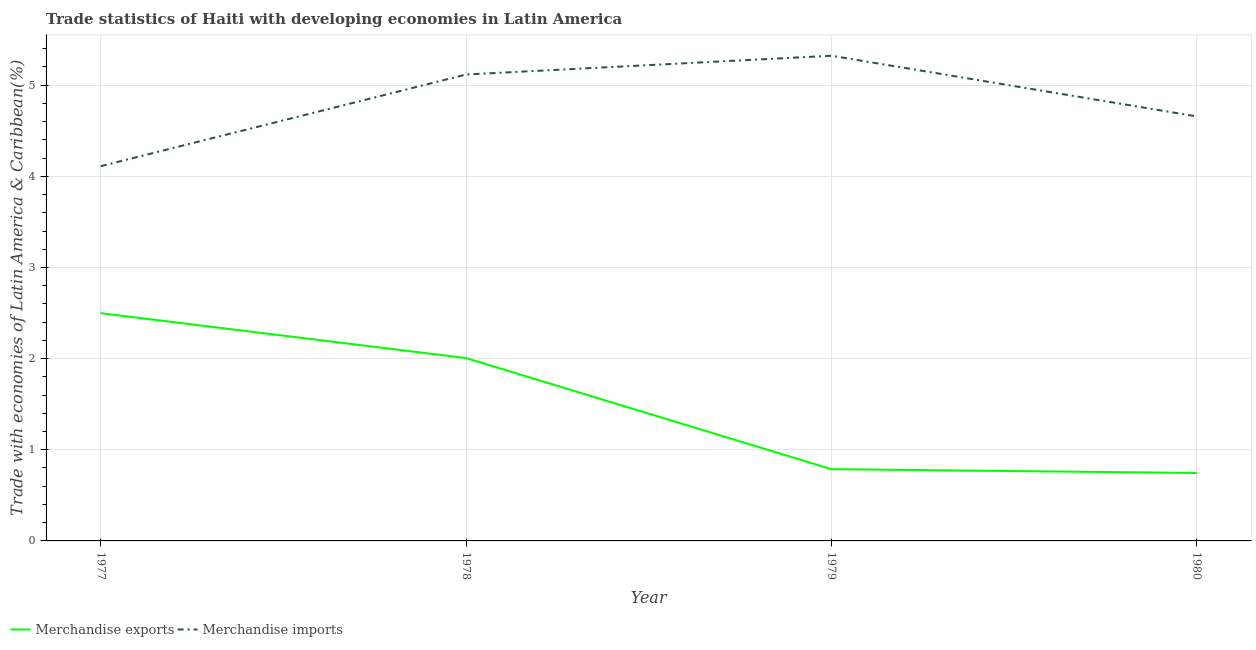Does the line corresponding to merchandise exports intersect with the line corresponding to merchandise imports?
Offer a terse response. No. What is the merchandise exports in 1980?
Provide a succinct answer. 0.75. Across all years, what is the maximum merchandise exports?
Provide a short and direct response. 2.5. Across all years, what is the minimum merchandise exports?
Your answer should be very brief. 0.75. In which year was the merchandise imports maximum?
Your answer should be very brief. 1979. What is the total merchandise imports in the graph?
Give a very brief answer. 19.21. What is the difference between the merchandise imports in 1978 and that in 1980?
Make the answer very short. 0.46. What is the difference between the merchandise exports in 1980 and the merchandise imports in 1977?
Give a very brief answer. -3.37. What is the average merchandise exports per year?
Provide a succinct answer. 1.51. In the year 1979, what is the difference between the merchandise exports and merchandise imports?
Provide a short and direct response. -4.54. What is the ratio of the merchandise exports in 1979 to that in 1980?
Make the answer very short. 1.06. Is the difference between the merchandise exports in 1977 and 1978 greater than the difference between the merchandise imports in 1977 and 1978?
Provide a succinct answer. Yes. What is the difference between the highest and the second highest merchandise exports?
Your answer should be compact. 0.49. What is the difference between the highest and the lowest merchandise imports?
Keep it short and to the point. 1.21. In how many years, is the merchandise imports greater than the average merchandise imports taken over all years?
Ensure brevity in your answer.  2. Is the merchandise exports strictly greater than the merchandise imports over the years?
Offer a terse response. No. What is the difference between two consecutive major ticks on the Y-axis?
Provide a succinct answer. 1. Does the graph contain grids?
Ensure brevity in your answer.  Yes. How many legend labels are there?
Your answer should be compact. 2. How are the legend labels stacked?
Make the answer very short. Horizontal. What is the title of the graph?
Offer a terse response. Trade statistics of Haiti with developing economies in Latin America. What is the label or title of the X-axis?
Offer a terse response. Year. What is the label or title of the Y-axis?
Ensure brevity in your answer.  Trade with economies of Latin America & Caribbean(%). What is the Trade with economies of Latin America & Caribbean(%) of Merchandise exports in 1977?
Offer a terse response. 2.5. What is the Trade with economies of Latin America & Caribbean(%) of Merchandise imports in 1977?
Provide a succinct answer. 4.11. What is the Trade with economies of Latin America & Caribbean(%) in Merchandise exports in 1978?
Make the answer very short. 2.01. What is the Trade with economies of Latin America & Caribbean(%) of Merchandise imports in 1978?
Offer a terse response. 5.12. What is the Trade with economies of Latin America & Caribbean(%) of Merchandise exports in 1979?
Provide a succinct answer. 0.79. What is the Trade with economies of Latin America & Caribbean(%) in Merchandise imports in 1979?
Your response must be concise. 5.32. What is the Trade with economies of Latin America & Caribbean(%) of Merchandise exports in 1980?
Make the answer very short. 0.75. What is the Trade with economies of Latin America & Caribbean(%) in Merchandise imports in 1980?
Offer a very short reply. 4.66. Across all years, what is the maximum Trade with economies of Latin America & Caribbean(%) of Merchandise exports?
Provide a short and direct response. 2.5. Across all years, what is the maximum Trade with economies of Latin America & Caribbean(%) in Merchandise imports?
Offer a very short reply. 5.32. Across all years, what is the minimum Trade with economies of Latin America & Caribbean(%) in Merchandise exports?
Your answer should be very brief. 0.75. Across all years, what is the minimum Trade with economies of Latin America & Caribbean(%) of Merchandise imports?
Ensure brevity in your answer.  4.11. What is the total Trade with economies of Latin America & Caribbean(%) of Merchandise exports in the graph?
Provide a short and direct response. 6.04. What is the total Trade with economies of Latin America & Caribbean(%) of Merchandise imports in the graph?
Offer a very short reply. 19.21. What is the difference between the Trade with economies of Latin America & Caribbean(%) of Merchandise exports in 1977 and that in 1978?
Give a very brief answer. 0.49. What is the difference between the Trade with economies of Latin America & Caribbean(%) in Merchandise imports in 1977 and that in 1978?
Your response must be concise. -1.01. What is the difference between the Trade with economies of Latin America & Caribbean(%) of Merchandise exports in 1977 and that in 1979?
Give a very brief answer. 1.71. What is the difference between the Trade with economies of Latin America & Caribbean(%) in Merchandise imports in 1977 and that in 1979?
Provide a short and direct response. -1.21. What is the difference between the Trade with economies of Latin America & Caribbean(%) of Merchandise exports in 1977 and that in 1980?
Offer a very short reply. 1.75. What is the difference between the Trade with economies of Latin America & Caribbean(%) of Merchandise imports in 1977 and that in 1980?
Make the answer very short. -0.55. What is the difference between the Trade with economies of Latin America & Caribbean(%) of Merchandise exports in 1978 and that in 1979?
Keep it short and to the point. 1.22. What is the difference between the Trade with economies of Latin America & Caribbean(%) of Merchandise imports in 1978 and that in 1979?
Provide a succinct answer. -0.21. What is the difference between the Trade with economies of Latin America & Caribbean(%) in Merchandise exports in 1978 and that in 1980?
Your answer should be compact. 1.26. What is the difference between the Trade with economies of Latin America & Caribbean(%) in Merchandise imports in 1978 and that in 1980?
Make the answer very short. 0.46. What is the difference between the Trade with economies of Latin America & Caribbean(%) in Merchandise exports in 1979 and that in 1980?
Your answer should be compact. 0.04. What is the difference between the Trade with economies of Latin America & Caribbean(%) of Merchandise imports in 1979 and that in 1980?
Ensure brevity in your answer.  0.67. What is the difference between the Trade with economies of Latin America & Caribbean(%) of Merchandise exports in 1977 and the Trade with economies of Latin America & Caribbean(%) of Merchandise imports in 1978?
Your response must be concise. -2.62. What is the difference between the Trade with economies of Latin America & Caribbean(%) of Merchandise exports in 1977 and the Trade with economies of Latin America & Caribbean(%) of Merchandise imports in 1979?
Provide a short and direct response. -2.82. What is the difference between the Trade with economies of Latin America & Caribbean(%) of Merchandise exports in 1977 and the Trade with economies of Latin America & Caribbean(%) of Merchandise imports in 1980?
Keep it short and to the point. -2.16. What is the difference between the Trade with economies of Latin America & Caribbean(%) of Merchandise exports in 1978 and the Trade with economies of Latin America & Caribbean(%) of Merchandise imports in 1979?
Give a very brief answer. -3.32. What is the difference between the Trade with economies of Latin America & Caribbean(%) in Merchandise exports in 1978 and the Trade with economies of Latin America & Caribbean(%) in Merchandise imports in 1980?
Your response must be concise. -2.65. What is the difference between the Trade with economies of Latin America & Caribbean(%) in Merchandise exports in 1979 and the Trade with economies of Latin America & Caribbean(%) in Merchandise imports in 1980?
Make the answer very short. -3.87. What is the average Trade with economies of Latin America & Caribbean(%) in Merchandise exports per year?
Provide a succinct answer. 1.51. What is the average Trade with economies of Latin America & Caribbean(%) in Merchandise imports per year?
Provide a succinct answer. 4.8. In the year 1977, what is the difference between the Trade with economies of Latin America & Caribbean(%) of Merchandise exports and Trade with economies of Latin America & Caribbean(%) of Merchandise imports?
Offer a terse response. -1.61. In the year 1978, what is the difference between the Trade with economies of Latin America & Caribbean(%) in Merchandise exports and Trade with economies of Latin America & Caribbean(%) in Merchandise imports?
Your answer should be compact. -3.11. In the year 1979, what is the difference between the Trade with economies of Latin America & Caribbean(%) in Merchandise exports and Trade with economies of Latin America & Caribbean(%) in Merchandise imports?
Your answer should be very brief. -4.54. In the year 1980, what is the difference between the Trade with economies of Latin America & Caribbean(%) in Merchandise exports and Trade with economies of Latin America & Caribbean(%) in Merchandise imports?
Your response must be concise. -3.91. What is the ratio of the Trade with economies of Latin America & Caribbean(%) of Merchandise exports in 1977 to that in 1978?
Your response must be concise. 1.25. What is the ratio of the Trade with economies of Latin America & Caribbean(%) in Merchandise imports in 1977 to that in 1978?
Offer a very short reply. 0.8. What is the ratio of the Trade with economies of Latin America & Caribbean(%) of Merchandise exports in 1977 to that in 1979?
Offer a very short reply. 3.17. What is the ratio of the Trade with economies of Latin America & Caribbean(%) of Merchandise imports in 1977 to that in 1979?
Make the answer very short. 0.77. What is the ratio of the Trade with economies of Latin America & Caribbean(%) of Merchandise exports in 1977 to that in 1980?
Your answer should be very brief. 3.35. What is the ratio of the Trade with economies of Latin America & Caribbean(%) of Merchandise imports in 1977 to that in 1980?
Give a very brief answer. 0.88. What is the ratio of the Trade with economies of Latin America & Caribbean(%) of Merchandise exports in 1978 to that in 1979?
Ensure brevity in your answer.  2.55. What is the ratio of the Trade with economies of Latin America & Caribbean(%) of Merchandise imports in 1978 to that in 1979?
Make the answer very short. 0.96. What is the ratio of the Trade with economies of Latin America & Caribbean(%) of Merchandise exports in 1978 to that in 1980?
Provide a short and direct response. 2.69. What is the ratio of the Trade with economies of Latin America & Caribbean(%) in Merchandise imports in 1978 to that in 1980?
Your answer should be very brief. 1.1. What is the ratio of the Trade with economies of Latin America & Caribbean(%) of Merchandise exports in 1979 to that in 1980?
Make the answer very short. 1.06. What is the ratio of the Trade with economies of Latin America & Caribbean(%) in Merchandise imports in 1979 to that in 1980?
Offer a very short reply. 1.14. What is the difference between the highest and the second highest Trade with economies of Latin America & Caribbean(%) of Merchandise exports?
Your response must be concise. 0.49. What is the difference between the highest and the second highest Trade with economies of Latin America & Caribbean(%) of Merchandise imports?
Provide a succinct answer. 0.21. What is the difference between the highest and the lowest Trade with economies of Latin America & Caribbean(%) in Merchandise exports?
Provide a short and direct response. 1.75. What is the difference between the highest and the lowest Trade with economies of Latin America & Caribbean(%) of Merchandise imports?
Keep it short and to the point. 1.21. 